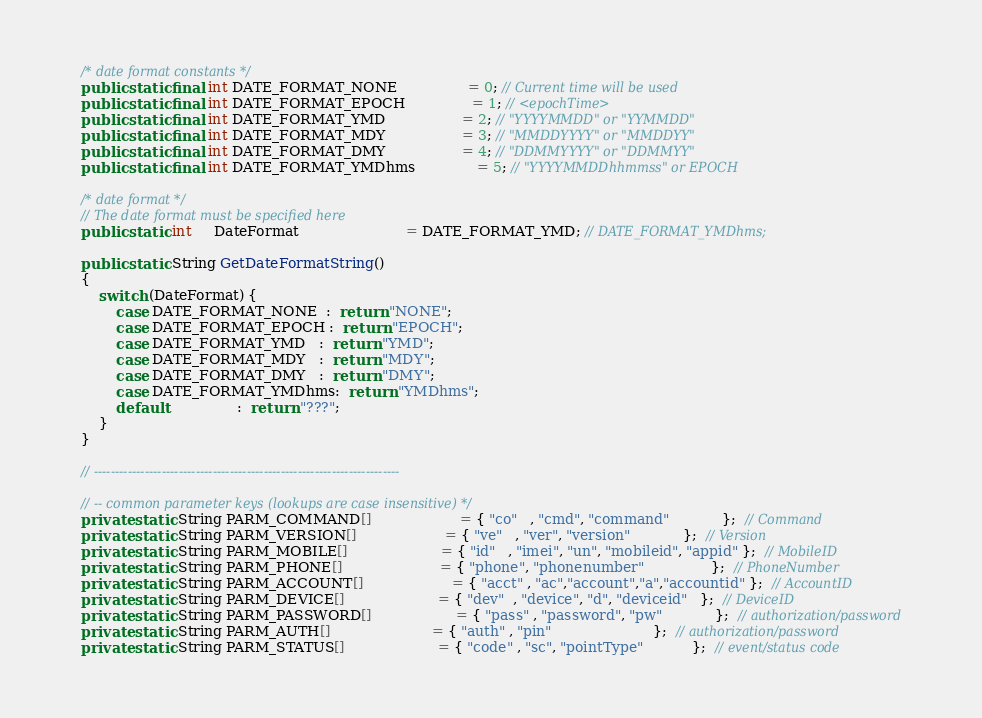<code> <loc_0><loc_0><loc_500><loc_500><_Java_>
    /* date format constants */
    public static final int DATE_FORMAT_NONE                = 0; // Current time will be used
    public static final int DATE_FORMAT_EPOCH               = 1; // <epochTime>
    public static final int DATE_FORMAT_YMD                 = 2; // "YYYYMMDD" or "YYMMDD"
    public static final int DATE_FORMAT_MDY                 = 3; // "MMDDYYYY" or "MMDDYY"
    public static final int DATE_FORMAT_DMY                 = 4; // "DDMMYYYY" or "DDMMYY"
    public static final int DATE_FORMAT_YMDhms              = 5; // "YYYYMMDDhhmmss" or EPOCH

    /* date format */
    // The date format must be specified here
    public static int     DateFormat                        = DATE_FORMAT_YMD; // DATE_FORMAT_YMDhms;

    public static String GetDateFormatString()
    {
        switch (DateFormat) {
            case DATE_FORMAT_NONE  :  return "NONE";
            case DATE_FORMAT_EPOCH :  return "EPOCH";
            case DATE_FORMAT_YMD   :  return "YMD";
            case DATE_FORMAT_MDY   :  return "MDY";
            case DATE_FORMAT_DMY   :  return "DMY";
            case DATE_FORMAT_YMDhms:  return "YMDhms";
            default                :  return "???";
        }
    }
    
    // ------------------------------------------------------------------------

    // -- common parameter keys (lookups are case insensitive) */
    private static String PARM_COMMAND[]                    = { "co"   , "cmd", "command"            };  // Command
    private static String PARM_VERSION[]                    = { "ve"   , "ver", "version"            };  // Version
    private static String PARM_MOBILE[]                     = { "id"   , "imei", "un", "mobileid", "appid" };  // MobileID
    private static String PARM_PHONE[]                      = { "phone", "phonenumber"               };  // PhoneNumber
    private static String PARM_ACCOUNT[]                    = { "acct" , "ac","account","a","accountid" };  // AccountID
    private static String PARM_DEVICE[]                     = { "dev"  , "device", "d", "deviceid"   };  // DeviceID
    private static String PARM_PASSWORD[]                   = { "pass" , "password", "pw"            };  // authorization/password
    private static String PARM_AUTH[]                       = { "auth" , "pin"                       };  // authorization/password
    private static String PARM_STATUS[]                     = { "code" , "sc", "pointType"           };  // event/status code</code> 